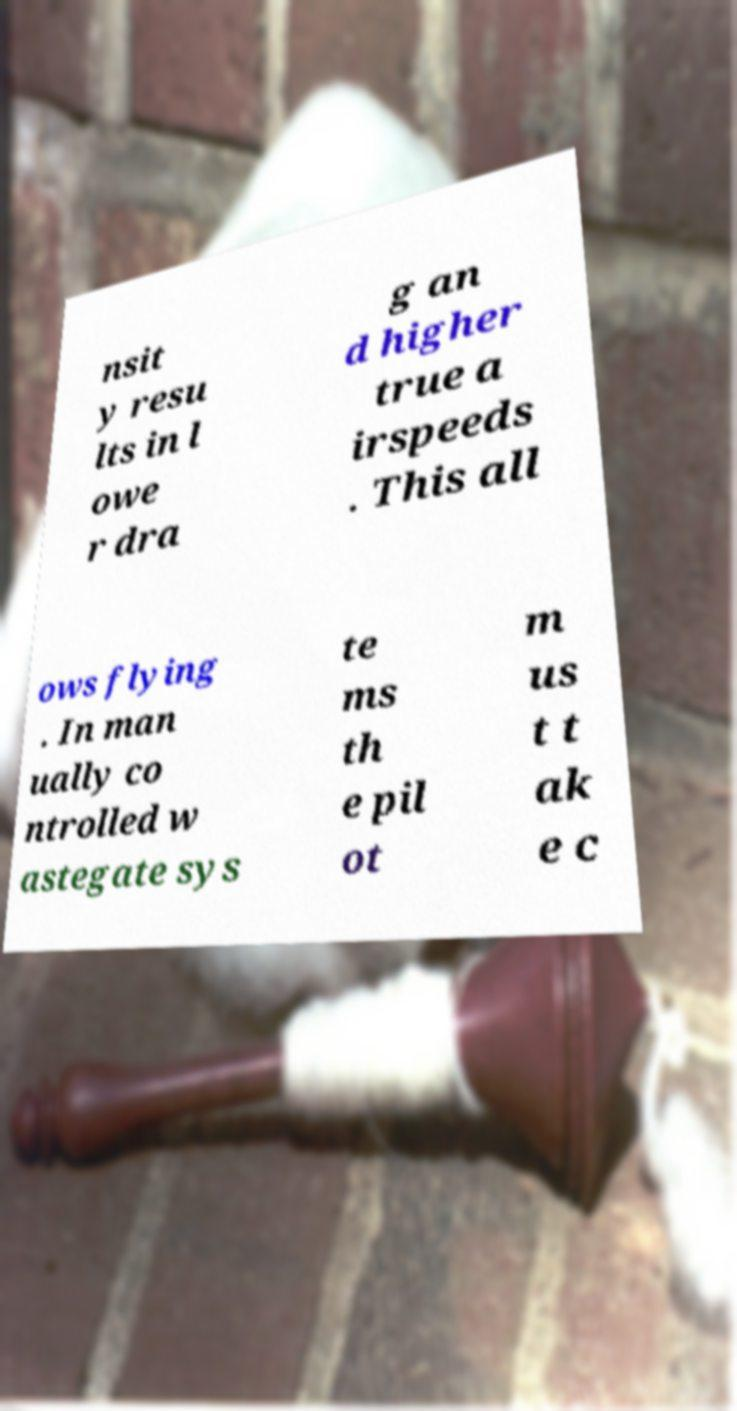What messages or text are displayed in this image? I need them in a readable, typed format. nsit y resu lts in l owe r dra g an d higher true a irspeeds . This all ows flying . In man ually co ntrolled w astegate sys te ms th e pil ot m us t t ak e c 